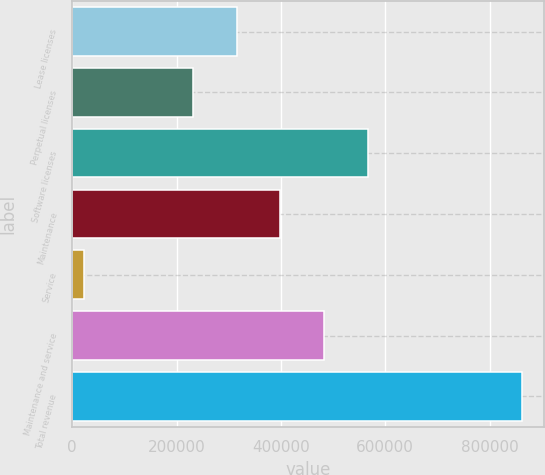Convert chart to OTSL. <chart><loc_0><loc_0><loc_500><loc_500><bar_chart><fcel>Lease licenses<fcel>Perpetual licenses<fcel>Software licenses<fcel>Maintenance<fcel>Service<fcel>Maintenance and service<fcel>Total revenue<nl><fcel>315089<fcel>231286<fcel>566498<fcel>398892<fcel>23231<fcel>482695<fcel>861260<nl></chart> 